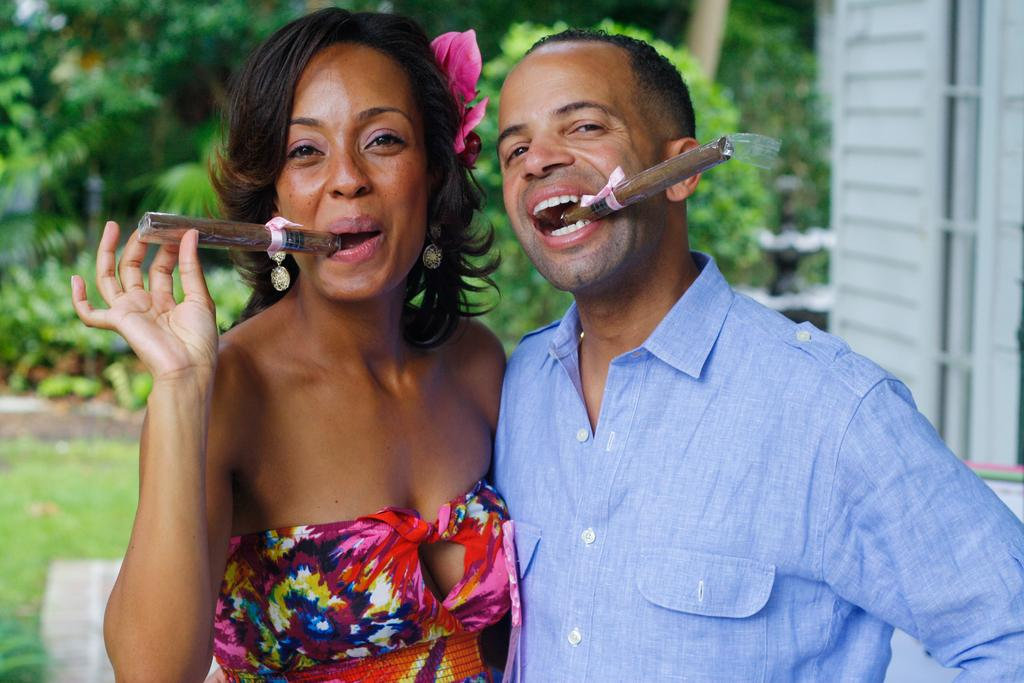How many people are in the image? There are people in the image, but the exact number is not specified. What are the people doing in the image? The people have objects in their mouths, which suggests they might be eating or performing some activity involving their mouths. What is the ground surface like in the image? There is grass on the ground in the image. What type of vegetation can be seen in the image? There are plants visible in the image. What color is the object on the right side of the image? There is a white-colored object on the right side of the image. Can you tell me how many rabbits are present in the image? There is no mention of rabbits in the image, so we cannot determine their presence or number. What type of spy equipment can be seen in the image? There is no indication of any spy equipment in the image; it primarily features people with objects in their mouths, grass, plants, and a white-colored object. 